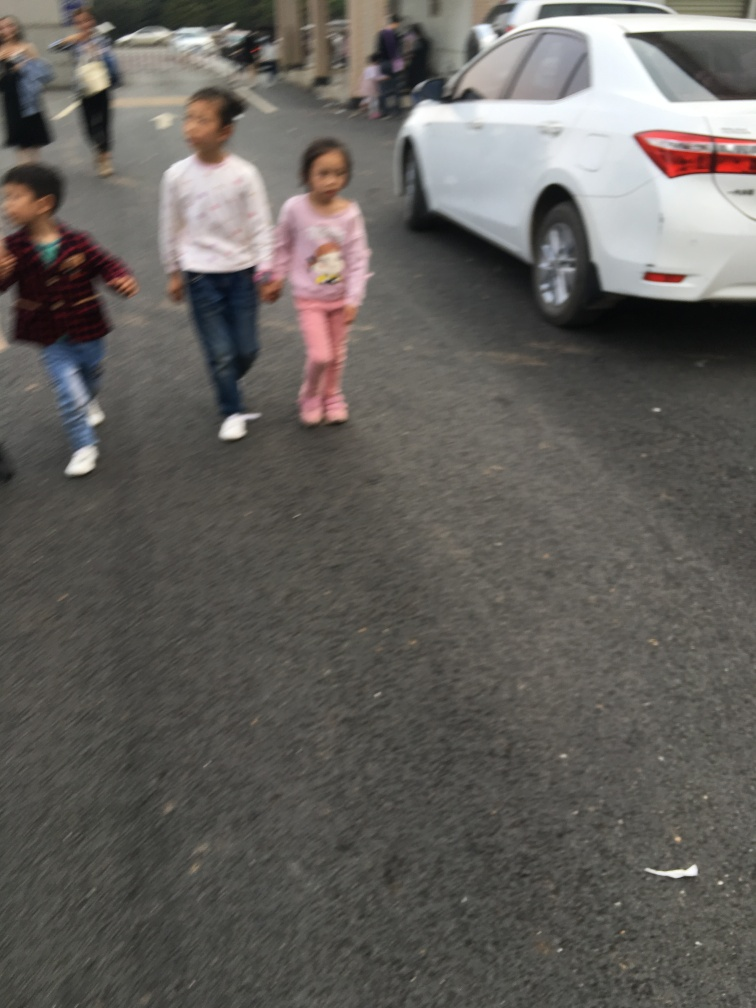Are there any quality issues with this image? Yes, the image is blurry which affects the clarity. There's significant motion blur, likely due to the movement of the subjects combined with a slow shutter speed. Additionally, it's not well-framed; the subjects are positioned randomly with the excess space at the top, and the focus seems to be neither on the background nor on the subjects. The composition and focus settings did not optimally capture the moment. 